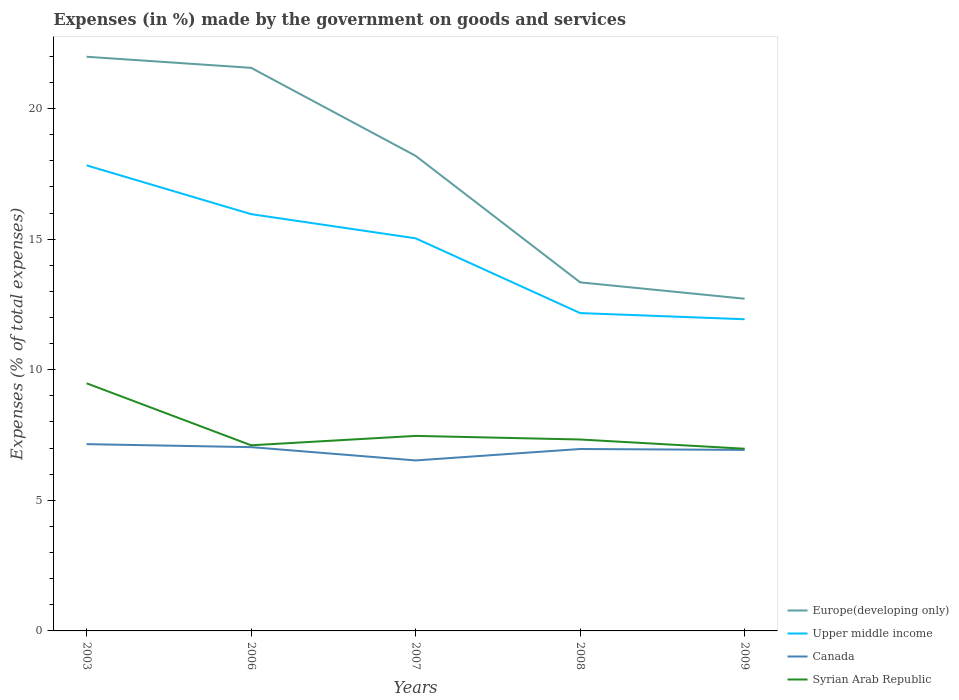Does the line corresponding to Europe(developing only) intersect with the line corresponding to Upper middle income?
Make the answer very short. No. Across all years, what is the maximum percentage of expenses made by the government on goods and services in Upper middle income?
Provide a short and direct response. 11.93. In which year was the percentage of expenses made by the government on goods and services in Upper middle income maximum?
Give a very brief answer. 2009. What is the total percentage of expenses made by the government on goods and services in Canada in the graph?
Provide a short and direct response. 0.11. What is the difference between the highest and the second highest percentage of expenses made by the government on goods and services in Upper middle income?
Keep it short and to the point. 5.89. What is the difference between the highest and the lowest percentage of expenses made by the government on goods and services in Upper middle income?
Offer a very short reply. 3. How many years are there in the graph?
Keep it short and to the point. 5. Are the values on the major ticks of Y-axis written in scientific E-notation?
Offer a very short reply. No. Does the graph contain any zero values?
Offer a very short reply. No. Does the graph contain grids?
Your answer should be compact. No. How many legend labels are there?
Make the answer very short. 4. What is the title of the graph?
Offer a very short reply. Expenses (in %) made by the government on goods and services. Does "Senegal" appear as one of the legend labels in the graph?
Provide a short and direct response. No. What is the label or title of the X-axis?
Your response must be concise. Years. What is the label or title of the Y-axis?
Offer a very short reply. Expenses (% of total expenses). What is the Expenses (% of total expenses) of Europe(developing only) in 2003?
Offer a very short reply. 21.98. What is the Expenses (% of total expenses) in Upper middle income in 2003?
Offer a very short reply. 17.82. What is the Expenses (% of total expenses) of Canada in 2003?
Your response must be concise. 7.15. What is the Expenses (% of total expenses) of Syrian Arab Republic in 2003?
Offer a very short reply. 9.48. What is the Expenses (% of total expenses) of Europe(developing only) in 2006?
Offer a very short reply. 21.56. What is the Expenses (% of total expenses) in Upper middle income in 2006?
Keep it short and to the point. 15.96. What is the Expenses (% of total expenses) of Canada in 2006?
Make the answer very short. 7.04. What is the Expenses (% of total expenses) of Syrian Arab Republic in 2006?
Offer a very short reply. 7.11. What is the Expenses (% of total expenses) in Europe(developing only) in 2007?
Your response must be concise. 18.19. What is the Expenses (% of total expenses) in Upper middle income in 2007?
Give a very brief answer. 15.03. What is the Expenses (% of total expenses) of Canada in 2007?
Ensure brevity in your answer.  6.53. What is the Expenses (% of total expenses) of Syrian Arab Republic in 2007?
Your answer should be very brief. 7.47. What is the Expenses (% of total expenses) in Europe(developing only) in 2008?
Ensure brevity in your answer.  13.35. What is the Expenses (% of total expenses) of Upper middle income in 2008?
Provide a succinct answer. 12.17. What is the Expenses (% of total expenses) in Canada in 2008?
Provide a succinct answer. 6.97. What is the Expenses (% of total expenses) in Syrian Arab Republic in 2008?
Ensure brevity in your answer.  7.33. What is the Expenses (% of total expenses) of Europe(developing only) in 2009?
Make the answer very short. 12.72. What is the Expenses (% of total expenses) in Upper middle income in 2009?
Provide a short and direct response. 11.93. What is the Expenses (% of total expenses) of Canada in 2009?
Provide a succinct answer. 6.93. What is the Expenses (% of total expenses) in Syrian Arab Republic in 2009?
Offer a very short reply. 6.98. Across all years, what is the maximum Expenses (% of total expenses) in Europe(developing only)?
Offer a very short reply. 21.98. Across all years, what is the maximum Expenses (% of total expenses) of Upper middle income?
Ensure brevity in your answer.  17.82. Across all years, what is the maximum Expenses (% of total expenses) of Canada?
Give a very brief answer. 7.15. Across all years, what is the maximum Expenses (% of total expenses) in Syrian Arab Republic?
Make the answer very short. 9.48. Across all years, what is the minimum Expenses (% of total expenses) of Europe(developing only)?
Make the answer very short. 12.72. Across all years, what is the minimum Expenses (% of total expenses) of Upper middle income?
Your answer should be compact. 11.93. Across all years, what is the minimum Expenses (% of total expenses) in Canada?
Offer a terse response. 6.53. Across all years, what is the minimum Expenses (% of total expenses) in Syrian Arab Republic?
Your answer should be compact. 6.98. What is the total Expenses (% of total expenses) of Europe(developing only) in the graph?
Offer a terse response. 87.8. What is the total Expenses (% of total expenses) of Upper middle income in the graph?
Make the answer very short. 72.92. What is the total Expenses (% of total expenses) in Canada in the graph?
Offer a terse response. 34.61. What is the total Expenses (% of total expenses) in Syrian Arab Republic in the graph?
Provide a succinct answer. 38.36. What is the difference between the Expenses (% of total expenses) of Europe(developing only) in 2003 and that in 2006?
Your answer should be very brief. 0.42. What is the difference between the Expenses (% of total expenses) of Upper middle income in 2003 and that in 2006?
Your response must be concise. 1.87. What is the difference between the Expenses (% of total expenses) in Canada in 2003 and that in 2006?
Ensure brevity in your answer.  0.11. What is the difference between the Expenses (% of total expenses) in Syrian Arab Republic in 2003 and that in 2006?
Your answer should be compact. 2.37. What is the difference between the Expenses (% of total expenses) in Europe(developing only) in 2003 and that in 2007?
Your answer should be compact. 3.79. What is the difference between the Expenses (% of total expenses) of Upper middle income in 2003 and that in 2007?
Provide a short and direct response. 2.79. What is the difference between the Expenses (% of total expenses) in Canada in 2003 and that in 2007?
Make the answer very short. 0.62. What is the difference between the Expenses (% of total expenses) in Syrian Arab Republic in 2003 and that in 2007?
Your response must be concise. 2.01. What is the difference between the Expenses (% of total expenses) in Europe(developing only) in 2003 and that in 2008?
Offer a very short reply. 8.64. What is the difference between the Expenses (% of total expenses) of Upper middle income in 2003 and that in 2008?
Keep it short and to the point. 5.66. What is the difference between the Expenses (% of total expenses) in Canada in 2003 and that in 2008?
Ensure brevity in your answer.  0.19. What is the difference between the Expenses (% of total expenses) of Syrian Arab Republic in 2003 and that in 2008?
Your answer should be compact. 2.15. What is the difference between the Expenses (% of total expenses) in Europe(developing only) in 2003 and that in 2009?
Your answer should be very brief. 9.26. What is the difference between the Expenses (% of total expenses) in Upper middle income in 2003 and that in 2009?
Offer a terse response. 5.89. What is the difference between the Expenses (% of total expenses) of Canada in 2003 and that in 2009?
Your answer should be compact. 0.22. What is the difference between the Expenses (% of total expenses) of Syrian Arab Republic in 2003 and that in 2009?
Make the answer very short. 2.51. What is the difference between the Expenses (% of total expenses) in Europe(developing only) in 2006 and that in 2007?
Your answer should be very brief. 3.37. What is the difference between the Expenses (% of total expenses) of Upper middle income in 2006 and that in 2007?
Provide a succinct answer. 0.93. What is the difference between the Expenses (% of total expenses) in Canada in 2006 and that in 2007?
Offer a very short reply. 0.51. What is the difference between the Expenses (% of total expenses) in Syrian Arab Republic in 2006 and that in 2007?
Your answer should be very brief. -0.36. What is the difference between the Expenses (% of total expenses) in Europe(developing only) in 2006 and that in 2008?
Your response must be concise. 8.21. What is the difference between the Expenses (% of total expenses) of Upper middle income in 2006 and that in 2008?
Offer a very short reply. 3.79. What is the difference between the Expenses (% of total expenses) in Canada in 2006 and that in 2008?
Provide a short and direct response. 0.07. What is the difference between the Expenses (% of total expenses) of Syrian Arab Republic in 2006 and that in 2008?
Your response must be concise. -0.22. What is the difference between the Expenses (% of total expenses) of Europe(developing only) in 2006 and that in 2009?
Your response must be concise. 8.84. What is the difference between the Expenses (% of total expenses) in Upper middle income in 2006 and that in 2009?
Keep it short and to the point. 4.02. What is the difference between the Expenses (% of total expenses) of Canada in 2006 and that in 2009?
Provide a succinct answer. 0.11. What is the difference between the Expenses (% of total expenses) of Syrian Arab Republic in 2006 and that in 2009?
Keep it short and to the point. 0.13. What is the difference between the Expenses (% of total expenses) of Europe(developing only) in 2007 and that in 2008?
Provide a short and direct response. 4.84. What is the difference between the Expenses (% of total expenses) of Upper middle income in 2007 and that in 2008?
Ensure brevity in your answer.  2.86. What is the difference between the Expenses (% of total expenses) in Canada in 2007 and that in 2008?
Offer a very short reply. -0.44. What is the difference between the Expenses (% of total expenses) of Syrian Arab Republic in 2007 and that in 2008?
Ensure brevity in your answer.  0.14. What is the difference between the Expenses (% of total expenses) in Europe(developing only) in 2007 and that in 2009?
Provide a short and direct response. 5.47. What is the difference between the Expenses (% of total expenses) of Upper middle income in 2007 and that in 2009?
Offer a terse response. 3.1. What is the difference between the Expenses (% of total expenses) of Canada in 2007 and that in 2009?
Offer a very short reply. -0.4. What is the difference between the Expenses (% of total expenses) in Syrian Arab Republic in 2007 and that in 2009?
Ensure brevity in your answer.  0.49. What is the difference between the Expenses (% of total expenses) of Europe(developing only) in 2008 and that in 2009?
Provide a succinct answer. 0.63. What is the difference between the Expenses (% of total expenses) in Upper middle income in 2008 and that in 2009?
Your answer should be very brief. 0.24. What is the difference between the Expenses (% of total expenses) in Canada in 2008 and that in 2009?
Ensure brevity in your answer.  0.03. What is the difference between the Expenses (% of total expenses) in Syrian Arab Republic in 2008 and that in 2009?
Give a very brief answer. 0.35. What is the difference between the Expenses (% of total expenses) of Europe(developing only) in 2003 and the Expenses (% of total expenses) of Upper middle income in 2006?
Your response must be concise. 6.03. What is the difference between the Expenses (% of total expenses) in Europe(developing only) in 2003 and the Expenses (% of total expenses) in Canada in 2006?
Offer a terse response. 14.95. What is the difference between the Expenses (% of total expenses) of Europe(developing only) in 2003 and the Expenses (% of total expenses) of Syrian Arab Republic in 2006?
Offer a very short reply. 14.88. What is the difference between the Expenses (% of total expenses) of Upper middle income in 2003 and the Expenses (% of total expenses) of Canada in 2006?
Ensure brevity in your answer.  10.79. What is the difference between the Expenses (% of total expenses) in Upper middle income in 2003 and the Expenses (% of total expenses) in Syrian Arab Republic in 2006?
Your answer should be compact. 10.72. What is the difference between the Expenses (% of total expenses) in Canada in 2003 and the Expenses (% of total expenses) in Syrian Arab Republic in 2006?
Ensure brevity in your answer.  0.04. What is the difference between the Expenses (% of total expenses) of Europe(developing only) in 2003 and the Expenses (% of total expenses) of Upper middle income in 2007?
Make the answer very short. 6.95. What is the difference between the Expenses (% of total expenses) in Europe(developing only) in 2003 and the Expenses (% of total expenses) in Canada in 2007?
Make the answer very short. 15.46. What is the difference between the Expenses (% of total expenses) of Europe(developing only) in 2003 and the Expenses (% of total expenses) of Syrian Arab Republic in 2007?
Your answer should be very brief. 14.52. What is the difference between the Expenses (% of total expenses) in Upper middle income in 2003 and the Expenses (% of total expenses) in Canada in 2007?
Offer a very short reply. 11.3. What is the difference between the Expenses (% of total expenses) in Upper middle income in 2003 and the Expenses (% of total expenses) in Syrian Arab Republic in 2007?
Provide a short and direct response. 10.36. What is the difference between the Expenses (% of total expenses) in Canada in 2003 and the Expenses (% of total expenses) in Syrian Arab Republic in 2007?
Provide a short and direct response. -0.32. What is the difference between the Expenses (% of total expenses) of Europe(developing only) in 2003 and the Expenses (% of total expenses) of Upper middle income in 2008?
Offer a terse response. 9.81. What is the difference between the Expenses (% of total expenses) in Europe(developing only) in 2003 and the Expenses (% of total expenses) in Canada in 2008?
Offer a very short reply. 15.02. What is the difference between the Expenses (% of total expenses) of Europe(developing only) in 2003 and the Expenses (% of total expenses) of Syrian Arab Republic in 2008?
Offer a terse response. 14.65. What is the difference between the Expenses (% of total expenses) in Upper middle income in 2003 and the Expenses (% of total expenses) in Canada in 2008?
Ensure brevity in your answer.  10.86. What is the difference between the Expenses (% of total expenses) of Upper middle income in 2003 and the Expenses (% of total expenses) of Syrian Arab Republic in 2008?
Your answer should be very brief. 10.5. What is the difference between the Expenses (% of total expenses) in Canada in 2003 and the Expenses (% of total expenses) in Syrian Arab Republic in 2008?
Your response must be concise. -0.18. What is the difference between the Expenses (% of total expenses) in Europe(developing only) in 2003 and the Expenses (% of total expenses) in Upper middle income in 2009?
Ensure brevity in your answer.  10.05. What is the difference between the Expenses (% of total expenses) in Europe(developing only) in 2003 and the Expenses (% of total expenses) in Canada in 2009?
Provide a succinct answer. 15.05. What is the difference between the Expenses (% of total expenses) in Europe(developing only) in 2003 and the Expenses (% of total expenses) in Syrian Arab Republic in 2009?
Offer a terse response. 15.01. What is the difference between the Expenses (% of total expenses) in Upper middle income in 2003 and the Expenses (% of total expenses) in Canada in 2009?
Your response must be concise. 10.89. What is the difference between the Expenses (% of total expenses) of Upper middle income in 2003 and the Expenses (% of total expenses) of Syrian Arab Republic in 2009?
Keep it short and to the point. 10.85. What is the difference between the Expenses (% of total expenses) in Canada in 2003 and the Expenses (% of total expenses) in Syrian Arab Republic in 2009?
Offer a very short reply. 0.18. What is the difference between the Expenses (% of total expenses) of Europe(developing only) in 2006 and the Expenses (% of total expenses) of Upper middle income in 2007?
Provide a succinct answer. 6.53. What is the difference between the Expenses (% of total expenses) of Europe(developing only) in 2006 and the Expenses (% of total expenses) of Canada in 2007?
Ensure brevity in your answer.  15.03. What is the difference between the Expenses (% of total expenses) of Europe(developing only) in 2006 and the Expenses (% of total expenses) of Syrian Arab Republic in 2007?
Offer a very short reply. 14.09. What is the difference between the Expenses (% of total expenses) in Upper middle income in 2006 and the Expenses (% of total expenses) in Canada in 2007?
Your response must be concise. 9.43. What is the difference between the Expenses (% of total expenses) of Upper middle income in 2006 and the Expenses (% of total expenses) of Syrian Arab Republic in 2007?
Make the answer very short. 8.49. What is the difference between the Expenses (% of total expenses) of Canada in 2006 and the Expenses (% of total expenses) of Syrian Arab Republic in 2007?
Offer a very short reply. -0.43. What is the difference between the Expenses (% of total expenses) of Europe(developing only) in 2006 and the Expenses (% of total expenses) of Upper middle income in 2008?
Provide a short and direct response. 9.39. What is the difference between the Expenses (% of total expenses) in Europe(developing only) in 2006 and the Expenses (% of total expenses) in Canada in 2008?
Your answer should be compact. 14.59. What is the difference between the Expenses (% of total expenses) of Europe(developing only) in 2006 and the Expenses (% of total expenses) of Syrian Arab Republic in 2008?
Offer a very short reply. 14.23. What is the difference between the Expenses (% of total expenses) in Upper middle income in 2006 and the Expenses (% of total expenses) in Canada in 2008?
Offer a very short reply. 8.99. What is the difference between the Expenses (% of total expenses) in Upper middle income in 2006 and the Expenses (% of total expenses) in Syrian Arab Republic in 2008?
Provide a short and direct response. 8.63. What is the difference between the Expenses (% of total expenses) of Canada in 2006 and the Expenses (% of total expenses) of Syrian Arab Republic in 2008?
Your response must be concise. -0.29. What is the difference between the Expenses (% of total expenses) of Europe(developing only) in 2006 and the Expenses (% of total expenses) of Upper middle income in 2009?
Keep it short and to the point. 9.63. What is the difference between the Expenses (% of total expenses) of Europe(developing only) in 2006 and the Expenses (% of total expenses) of Canada in 2009?
Offer a terse response. 14.63. What is the difference between the Expenses (% of total expenses) of Europe(developing only) in 2006 and the Expenses (% of total expenses) of Syrian Arab Republic in 2009?
Ensure brevity in your answer.  14.58. What is the difference between the Expenses (% of total expenses) of Upper middle income in 2006 and the Expenses (% of total expenses) of Canada in 2009?
Offer a very short reply. 9.03. What is the difference between the Expenses (% of total expenses) in Upper middle income in 2006 and the Expenses (% of total expenses) in Syrian Arab Republic in 2009?
Keep it short and to the point. 8.98. What is the difference between the Expenses (% of total expenses) in Canada in 2006 and the Expenses (% of total expenses) in Syrian Arab Republic in 2009?
Provide a succinct answer. 0.06. What is the difference between the Expenses (% of total expenses) in Europe(developing only) in 2007 and the Expenses (% of total expenses) in Upper middle income in 2008?
Offer a terse response. 6.02. What is the difference between the Expenses (% of total expenses) in Europe(developing only) in 2007 and the Expenses (% of total expenses) in Canada in 2008?
Your answer should be compact. 11.22. What is the difference between the Expenses (% of total expenses) in Europe(developing only) in 2007 and the Expenses (% of total expenses) in Syrian Arab Republic in 2008?
Your answer should be compact. 10.86. What is the difference between the Expenses (% of total expenses) of Upper middle income in 2007 and the Expenses (% of total expenses) of Canada in 2008?
Offer a very short reply. 8.07. What is the difference between the Expenses (% of total expenses) of Upper middle income in 2007 and the Expenses (% of total expenses) of Syrian Arab Republic in 2008?
Your response must be concise. 7.7. What is the difference between the Expenses (% of total expenses) in Canada in 2007 and the Expenses (% of total expenses) in Syrian Arab Republic in 2008?
Provide a short and direct response. -0.8. What is the difference between the Expenses (% of total expenses) of Europe(developing only) in 2007 and the Expenses (% of total expenses) of Upper middle income in 2009?
Your answer should be very brief. 6.26. What is the difference between the Expenses (% of total expenses) of Europe(developing only) in 2007 and the Expenses (% of total expenses) of Canada in 2009?
Offer a very short reply. 11.26. What is the difference between the Expenses (% of total expenses) of Europe(developing only) in 2007 and the Expenses (% of total expenses) of Syrian Arab Republic in 2009?
Offer a terse response. 11.21. What is the difference between the Expenses (% of total expenses) in Upper middle income in 2007 and the Expenses (% of total expenses) in Canada in 2009?
Make the answer very short. 8.1. What is the difference between the Expenses (% of total expenses) of Upper middle income in 2007 and the Expenses (% of total expenses) of Syrian Arab Republic in 2009?
Your answer should be very brief. 8.06. What is the difference between the Expenses (% of total expenses) of Canada in 2007 and the Expenses (% of total expenses) of Syrian Arab Republic in 2009?
Make the answer very short. -0.45. What is the difference between the Expenses (% of total expenses) of Europe(developing only) in 2008 and the Expenses (% of total expenses) of Upper middle income in 2009?
Your answer should be compact. 1.41. What is the difference between the Expenses (% of total expenses) in Europe(developing only) in 2008 and the Expenses (% of total expenses) in Canada in 2009?
Give a very brief answer. 6.42. What is the difference between the Expenses (% of total expenses) in Europe(developing only) in 2008 and the Expenses (% of total expenses) in Syrian Arab Republic in 2009?
Keep it short and to the point. 6.37. What is the difference between the Expenses (% of total expenses) of Upper middle income in 2008 and the Expenses (% of total expenses) of Canada in 2009?
Your response must be concise. 5.24. What is the difference between the Expenses (% of total expenses) of Upper middle income in 2008 and the Expenses (% of total expenses) of Syrian Arab Republic in 2009?
Give a very brief answer. 5.19. What is the difference between the Expenses (% of total expenses) in Canada in 2008 and the Expenses (% of total expenses) in Syrian Arab Republic in 2009?
Offer a terse response. -0.01. What is the average Expenses (% of total expenses) in Europe(developing only) per year?
Offer a very short reply. 17.56. What is the average Expenses (% of total expenses) in Upper middle income per year?
Give a very brief answer. 14.58. What is the average Expenses (% of total expenses) in Canada per year?
Offer a terse response. 6.92. What is the average Expenses (% of total expenses) in Syrian Arab Republic per year?
Your response must be concise. 7.67. In the year 2003, what is the difference between the Expenses (% of total expenses) of Europe(developing only) and Expenses (% of total expenses) of Upper middle income?
Your response must be concise. 4.16. In the year 2003, what is the difference between the Expenses (% of total expenses) of Europe(developing only) and Expenses (% of total expenses) of Canada?
Ensure brevity in your answer.  14.83. In the year 2003, what is the difference between the Expenses (% of total expenses) in Europe(developing only) and Expenses (% of total expenses) in Syrian Arab Republic?
Offer a terse response. 12.5. In the year 2003, what is the difference between the Expenses (% of total expenses) of Upper middle income and Expenses (% of total expenses) of Canada?
Your answer should be very brief. 10.67. In the year 2003, what is the difference between the Expenses (% of total expenses) in Upper middle income and Expenses (% of total expenses) in Syrian Arab Republic?
Your answer should be very brief. 8.34. In the year 2003, what is the difference between the Expenses (% of total expenses) in Canada and Expenses (% of total expenses) in Syrian Arab Republic?
Make the answer very short. -2.33. In the year 2006, what is the difference between the Expenses (% of total expenses) of Europe(developing only) and Expenses (% of total expenses) of Upper middle income?
Offer a terse response. 5.6. In the year 2006, what is the difference between the Expenses (% of total expenses) of Europe(developing only) and Expenses (% of total expenses) of Canada?
Offer a terse response. 14.52. In the year 2006, what is the difference between the Expenses (% of total expenses) in Europe(developing only) and Expenses (% of total expenses) in Syrian Arab Republic?
Your answer should be compact. 14.45. In the year 2006, what is the difference between the Expenses (% of total expenses) of Upper middle income and Expenses (% of total expenses) of Canada?
Give a very brief answer. 8.92. In the year 2006, what is the difference between the Expenses (% of total expenses) in Upper middle income and Expenses (% of total expenses) in Syrian Arab Republic?
Make the answer very short. 8.85. In the year 2006, what is the difference between the Expenses (% of total expenses) in Canada and Expenses (% of total expenses) in Syrian Arab Republic?
Your response must be concise. -0.07. In the year 2007, what is the difference between the Expenses (% of total expenses) of Europe(developing only) and Expenses (% of total expenses) of Upper middle income?
Your answer should be compact. 3.16. In the year 2007, what is the difference between the Expenses (% of total expenses) in Europe(developing only) and Expenses (% of total expenses) in Canada?
Your response must be concise. 11.66. In the year 2007, what is the difference between the Expenses (% of total expenses) in Europe(developing only) and Expenses (% of total expenses) in Syrian Arab Republic?
Provide a short and direct response. 10.72. In the year 2007, what is the difference between the Expenses (% of total expenses) of Upper middle income and Expenses (% of total expenses) of Canada?
Your response must be concise. 8.5. In the year 2007, what is the difference between the Expenses (% of total expenses) in Upper middle income and Expenses (% of total expenses) in Syrian Arab Republic?
Your answer should be compact. 7.56. In the year 2007, what is the difference between the Expenses (% of total expenses) of Canada and Expenses (% of total expenses) of Syrian Arab Republic?
Provide a short and direct response. -0.94. In the year 2008, what is the difference between the Expenses (% of total expenses) of Europe(developing only) and Expenses (% of total expenses) of Upper middle income?
Ensure brevity in your answer.  1.18. In the year 2008, what is the difference between the Expenses (% of total expenses) of Europe(developing only) and Expenses (% of total expenses) of Canada?
Ensure brevity in your answer.  6.38. In the year 2008, what is the difference between the Expenses (% of total expenses) in Europe(developing only) and Expenses (% of total expenses) in Syrian Arab Republic?
Offer a very short reply. 6.02. In the year 2008, what is the difference between the Expenses (% of total expenses) in Upper middle income and Expenses (% of total expenses) in Canada?
Keep it short and to the point. 5.2. In the year 2008, what is the difference between the Expenses (% of total expenses) of Upper middle income and Expenses (% of total expenses) of Syrian Arab Republic?
Your answer should be compact. 4.84. In the year 2008, what is the difference between the Expenses (% of total expenses) of Canada and Expenses (% of total expenses) of Syrian Arab Republic?
Provide a short and direct response. -0.36. In the year 2009, what is the difference between the Expenses (% of total expenses) of Europe(developing only) and Expenses (% of total expenses) of Upper middle income?
Provide a short and direct response. 0.79. In the year 2009, what is the difference between the Expenses (% of total expenses) in Europe(developing only) and Expenses (% of total expenses) in Canada?
Your answer should be very brief. 5.79. In the year 2009, what is the difference between the Expenses (% of total expenses) of Europe(developing only) and Expenses (% of total expenses) of Syrian Arab Republic?
Provide a short and direct response. 5.74. In the year 2009, what is the difference between the Expenses (% of total expenses) in Upper middle income and Expenses (% of total expenses) in Canada?
Your answer should be very brief. 5. In the year 2009, what is the difference between the Expenses (% of total expenses) of Upper middle income and Expenses (% of total expenses) of Syrian Arab Republic?
Offer a very short reply. 4.96. In the year 2009, what is the difference between the Expenses (% of total expenses) of Canada and Expenses (% of total expenses) of Syrian Arab Republic?
Give a very brief answer. -0.04. What is the ratio of the Expenses (% of total expenses) in Europe(developing only) in 2003 to that in 2006?
Your answer should be very brief. 1.02. What is the ratio of the Expenses (% of total expenses) in Upper middle income in 2003 to that in 2006?
Your answer should be compact. 1.12. What is the ratio of the Expenses (% of total expenses) in Canada in 2003 to that in 2006?
Your answer should be very brief. 1.02. What is the ratio of the Expenses (% of total expenses) in Syrian Arab Republic in 2003 to that in 2006?
Your answer should be very brief. 1.33. What is the ratio of the Expenses (% of total expenses) of Europe(developing only) in 2003 to that in 2007?
Make the answer very short. 1.21. What is the ratio of the Expenses (% of total expenses) in Upper middle income in 2003 to that in 2007?
Ensure brevity in your answer.  1.19. What is the ratio of the Expenses (% of total expenses) of Canada in 2003 to that in 2007?
Keep it short and to the point. 1.1. What is the ratio of the Expenses (% of total expenses) in Syrian Arab Republic in 2003 to that in 2007?
Your answer should be compact. 1.27. What is the ratio of the Expenses (% of total expenses) in Europe(developing only) in 2003 to that in 2008?
Give a very brief answer. 1.65. What is the ratio of the Expenses (% of total expenses) of Upper middle income in 2003 to that in 2008?
Ensure brevity in your answer.  1.46. What is the ratio of the Expenses (% of total expenses) of Canada in 2003 to that in 2008?
Your answer should be compact. 1.03. What is the ratio of the Expenses (% of total expenses) of Syrian Arab Republic in 2003 to that in 2008?
Provide a short and direct response. 1.29. What is the ratio of the Expenses (% of total expenses) of Europe(developing only) in 2003 to that in 2009?
Give a very brief answer. 1.73. What is the ratio of the Expenses (% of total expenses) of Upper middle income in 2003 to that in 2009?
Provide a short and direct response. 1.49. What is the ratio of the Expenses (% of total expenses) of Canada in 2003 to that in 2009?
Your answer should be compact. 1.03. What is the ratio of the Expenses (% of total expenses) in Syrian Arab Republic in 2003 to that in 2009?
Provide a short and direct response. 1.36. What is the ratio of the Expenses (% of total expenses) of Europe(developing only) in 2006 to that in 2007?
Provide a succinct answer. 1.19. What is the ratio of the Expenses (% of total expenses) of Upper middle income in 2006 to that in 2007?
Make the answer very short. 1.06. What is the ratio of the Expenses (% of total expenses) in Canada in 2006 to that in 2007?
Your response must be concise. 1.08. What is the ratio of the Expenses (% of total expenses) in Syrian Arab Republic in 2006 to that in 2007?
Provide a succinct answer. 0.95. What is the ratio of the Expenses (% of total expenses) of Europe(developing only) in 2006 to that in 2008?
Give a very brief answer. 1.62. What is the ratio of the Expenses (% of total expenses) in Upper middle income in 2006 to that in 2008?
Keep it short and to the point. 1.31. What is the ratio of the Expenses (% of total expenses) in Canada in 2006 to that in 2008?
Ensure brevity in your answer.  1.01. What is the ratio of the Expenses (% of total expenses) of Syrian Arab Republic in 2006 to that in 2008?
Ensure brevity in your answer.  0.97. What is the ratio of the Expenses (% of total expenses) of Europe(developing only) in 2006 to that in 2009?
Make the answer very short. 1.7. What is the ratio of the Expenses (% of total expenses) in Upper middle income in 2006 to that in 2009?
Your answer should be very brief. 1.34. What is the ratio of the Expenses (% of total expenses) of Canada in 2006 to that in 2009?
Keep it short and to the point. 1.02. What is the ratio of the Expenses (% of total expenses) of Syrian Arab Republic in 2006 to that in 2009?
Your answer should be compact. 1.02. What is the ratio of the Expenses (% of total expenses) in Europe(developing only) in 2007 to that in 2008?
Offer a very short reply. 1.36. What is the ratio of the Expenses (% of total expenses) of Upper middle income in 2007 to that in 2008?
Make the answer very short. 1.24. What is the ratio of the Expenses (% of total expenses) in Canada in 2007 to that in 2008?
Offer a very short reply. 0.94. What is the ratio of the Expenses (% of total expenses) in Syrian Arab Republic in 2007 to that in 2008?
Offer a very short reply. 1.02. What is the ratio of the Expenses (% of total expenses) of Europe(developing only) in 2007 to that in 2009?
Keep it short and to the point. 1.43. What is the ratio of the Expenses (% of total expenses) of Upper middle income in 2007 to that in 2009?
Your response must be concise. 1.26. What is the ratio of the Expenses (% of total expenses) of Canada in 2007 to that in 2009?
Your answer should be compact. 0.94. What is the ratio of the Expenses (% of total expenses) in Syrian Arab Republic in 2007 to that in 2009?
Make the answer very short. 1.07. What is the ratio of the Expenses (% of total expenses) of Europe(developing only) in 2008 to that in 2009?
Offer a very short reply. 1.05. What is the ratio of the Expenses (% of total expenses) of Upper middle income in 2008 to that in 2009?
Offer a very short reply. 1.02. What is the ratio of the Expenses (% of total expenses) in Canada in 2008 to that in 2009?
Your answer should be very brief. 1. What is the ratio of the Expenses (% of total expenses) in Syrian Arab Republic in 2008 to that in 2009?
Give a very brief answer. 1.05. What is the difference between the highest and the second highest Expenses (% of total expenses) of Europe(developing only)?
Offer a very short reply. 0.42. What is the difference between the highest and the second highest Expenses (% of total expenses) in Upper middle income?
Provide a succinct answer. 1.87. What is the difference between the highest and the second highest Expenses (% of total expenses) of Canada?
Offer a very short reply. 0.11. What is the difference between the highest and the second highest Expenses (% of total expenses) of Syrian Arab Republic?
Your response must be concise. 2.01. What is the difference between the highest and the lowest Expenses (% of total expenses) in Europe(developing only)?
Offer a very short reply. 9.26. What is the difference between the highest and the lowest Expenses (% of total expenses) in Upper middle income?
Keep it short and to the point. 5.89. What is the difference between the highest and the lowest Expenses (% of total expenses) in Canada?
Provide a short and direct response. 0.62. What is the difference between the highest and the lowest Expenses (% of total expenses) in Syrian Arab Republic?
Your answer should be very brief. 2.51. 